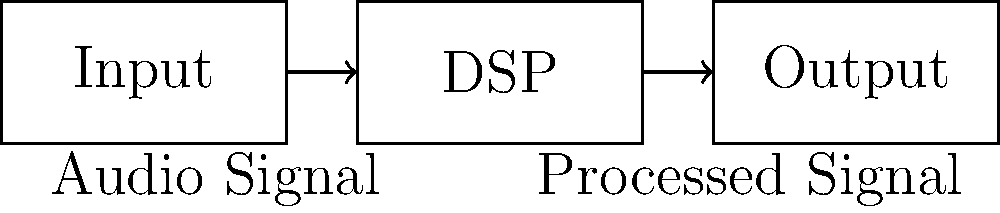In the basic audio plugin architecture shown above, what is the correct order of signal flow, and what happens in the DSP (Digital Signal Processing) block? To understand the signal flow in this basic audio plugin architecture, let's break it down step-by-step:

1. Input: The audio signal enters the plugin through the input block. This is typically a digital audio signal, represented as a series of samples.

2. DSP (Digital Signal Processing): The signal then flows into the DSP block. This is where the core processing of the audio plugin takes place. In this block:
   a) The incoming digital audio signal is manipulated according to the plugin's purpose.
   b) Various algorithms can be applied, such as filtering, compression, distortion, or any other effect the plugin is designed to achieve.
   c) The processing is done in real-time, sample by sample or in small blocks of samples.

3. Output: After processing, the modified signal flows to the output block. This block prepares the processed audio for output, ensuring it's in the correct format for playback or further processing in the audio production chain.

The signal flow is linear in this case: Input → DSP → Output. Each block represents a crucial stage in the plugin's operation, with the DSP block being the heart of the plugin where the actual audio manipulation occurs.
Answer: Input → DSP (audio signal processing) → Output 